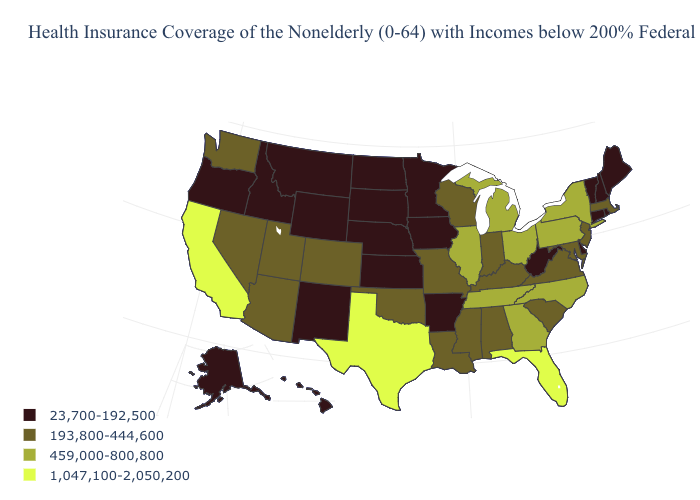Name the states that have a value in the range 193,800-444,600?
Give a very brief answer. Alabama, Arizona, Colorado, Indiana, Kentucky, Louisiana, Maryland, Massachusetts, Mississippi, Missouri, Nevada, New Jersey, Oklahoma, South Carolina, Utah, Virginia, Washington, Wisconsin. Does the map have missing data?
Short answer required. No. Does the map have missing data?
Keep it brief. No. Among the states that border Massachusetts , does Vermont have the highest value?
Concise answer only. No. Name the states that have a value in the range 23,700-192,500?
Give a very brief answer. Alaska, Arkansas, Connecticut, Delaware, Hawaii, Idaho, Iowa, Kansas, Maine, Minnesota, Montana, Nebraska, New Hampshire, New Mexico, North Dakota, Oregon, Rhode Island, South Dakota, Vermont, West Virginia, Wyoming. Does West Virginia have the lowest value in the South?
Short answer required. Yes. Does Arkansas have the lowest value in the USA?
Be succinct. Yes. Does Alaska have the same value as Washington?
Give a very brief answer. No. What is the value of California?
Short answer required. 1,047,100-2,050,200. Among the states that border West Virginia , which have the lowest value?
Be succinct. Kentucky, Maryland, Virginia. What is the value of Wisconsin?
Concise answer only. 193,800-444,600. What is the highest value in the Northeast ?
Write a very short answer. 459,000-800,800. Does Arizona have the lowest value in the West?
Short answer required. No. What is the value of South Dakota?
Keep it brief. 23,700-192,500. Does the map have missing data?
Keep it brief. No. 